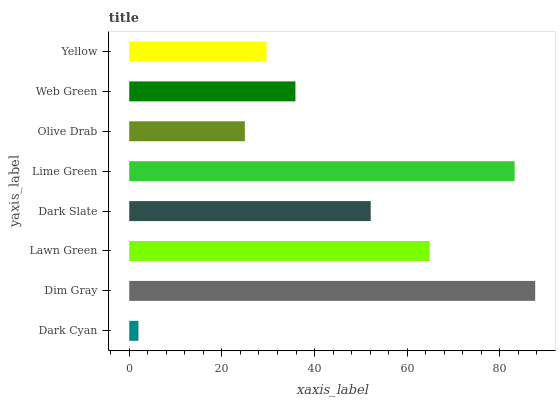Is Dark Cyan the minimum?
Answer yes or no. Yes. Is Dim Gray the maximum?
Answer yes or no. Yes. Is Lawn Green the minimum?
Answer yes or no. No. Is Lawn Green the maximum?
Answer yes or no. No. Is Dim Gray greater than Lawn Green?
Answer yes or no. Yes. Is Lawn Green less than Dim Gray?
Answer yes or no. Yes. Is Lawn Green greater than Dim Gray?
Answer yes or no. No. Is Dim Gray less than Lawn Green?
Answer yes or no. No. Is Dark Slate the high median?
Answer yes or no. Yes. Is Web Green the low median?
Answer yes or no. Yes. Is Dark Cyan the high median?
Answer yes or no. No. Is Olive Drab the low median?
Answer yes or no. No. 